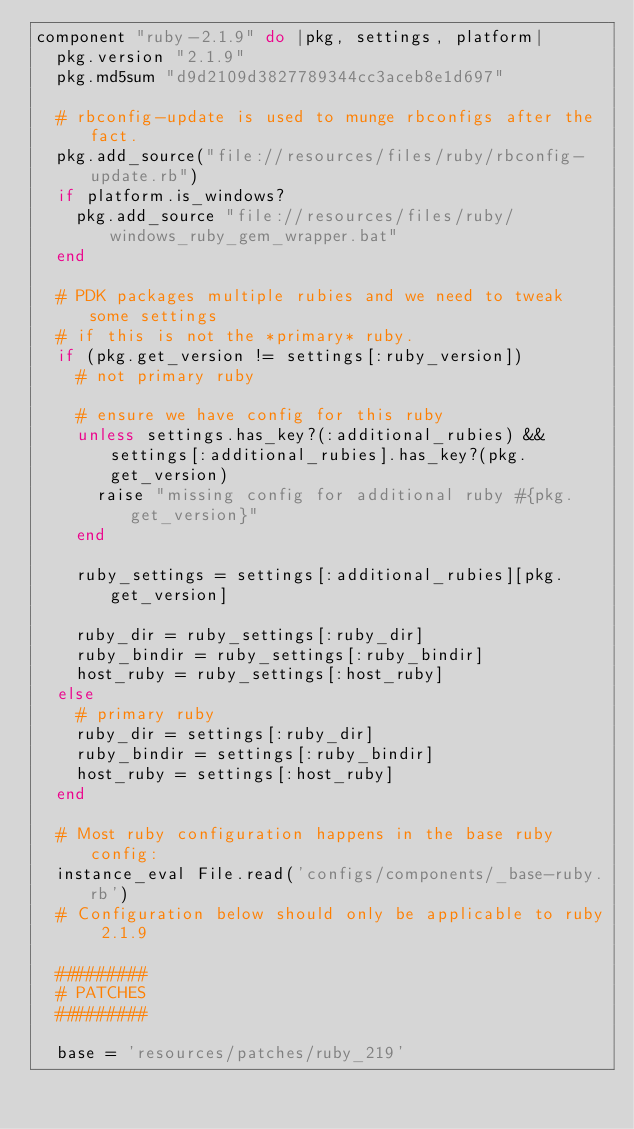<code> <loc_0><loc_0><loc_500><loc_500><_Ruby_>component "ruby-2.1.9" do |pkg, settings, platform|
  pkg.version "2.1.9"
  pkg.md5sum "d9d2109d3827789344cc3aceb8e1d697"

  # rbconfig-update is used to munge rbconfigs after the fact.
  pkg.add_source("file://resources/files/ruby/rbconfig-update.rb")
  if platform.is_windows?
    pkg.add_source "file://resources/files/ruby/windows_ruby_gem_wrapper.bat"
  end

  # PDK packages multiple rubies and we need to tweak some settings
  # if this is not the *primary* ruby.
  if (pkg.get_version != settings[:ruby_version])
    # not primary ruby

    # ensure we have config for this ruby
    unless settings.has_key?(:additional_rubies) && settings[:additional_rubies].has_key?(pkg.get_version)
      raise "missing config for additional ruby #{pkg.get_version}"
    end

    ruby_settings = settings[:additional_rubies][pkg.get_version]

    ruby_dir = ruby_settings[:ruby_dir]
    ruby_bindir = ruby_settings[:ruby_bindir]
    host_ruby = ruby_settings[:host_ruby]
  else
    # primary ruby
    ruby_dir = settings[:ruby_dir]
    ruby_bindir = settings[:ruby_bindir]
    host_ruby = settings[:host_ruby]
  end

  # Most ruby configuration happens in the base ruby config:
  instance_eval File.read('configs/components/_base-ruby.rb')
  # Configuration below should only be applicable to ruby 2.1.9

  #########
  # PATCHES
  #########

  base = 'resources/patches/ruby_219'</code> 